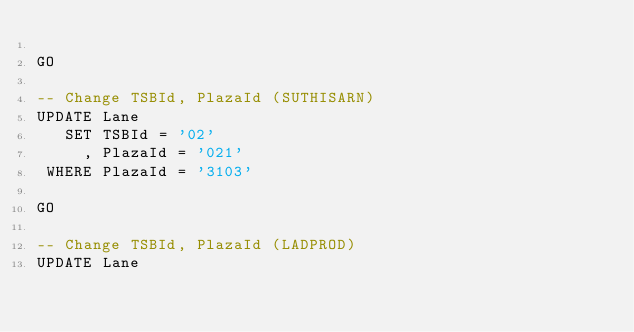Convert code to text. <code><loc_0><loc_0><loc_500><loc_500><_SQL_>
GO

-- Change TSBId, PlazaId (SUTHISARN)
UPDATE Lane
   SET TSBId = '02'
     , PlazaId = '021'
 WHERE PlazaId = '3103'

GO

-- Change TSBId, PlazaId (LADPROD)
UPDATE Lane</code> 